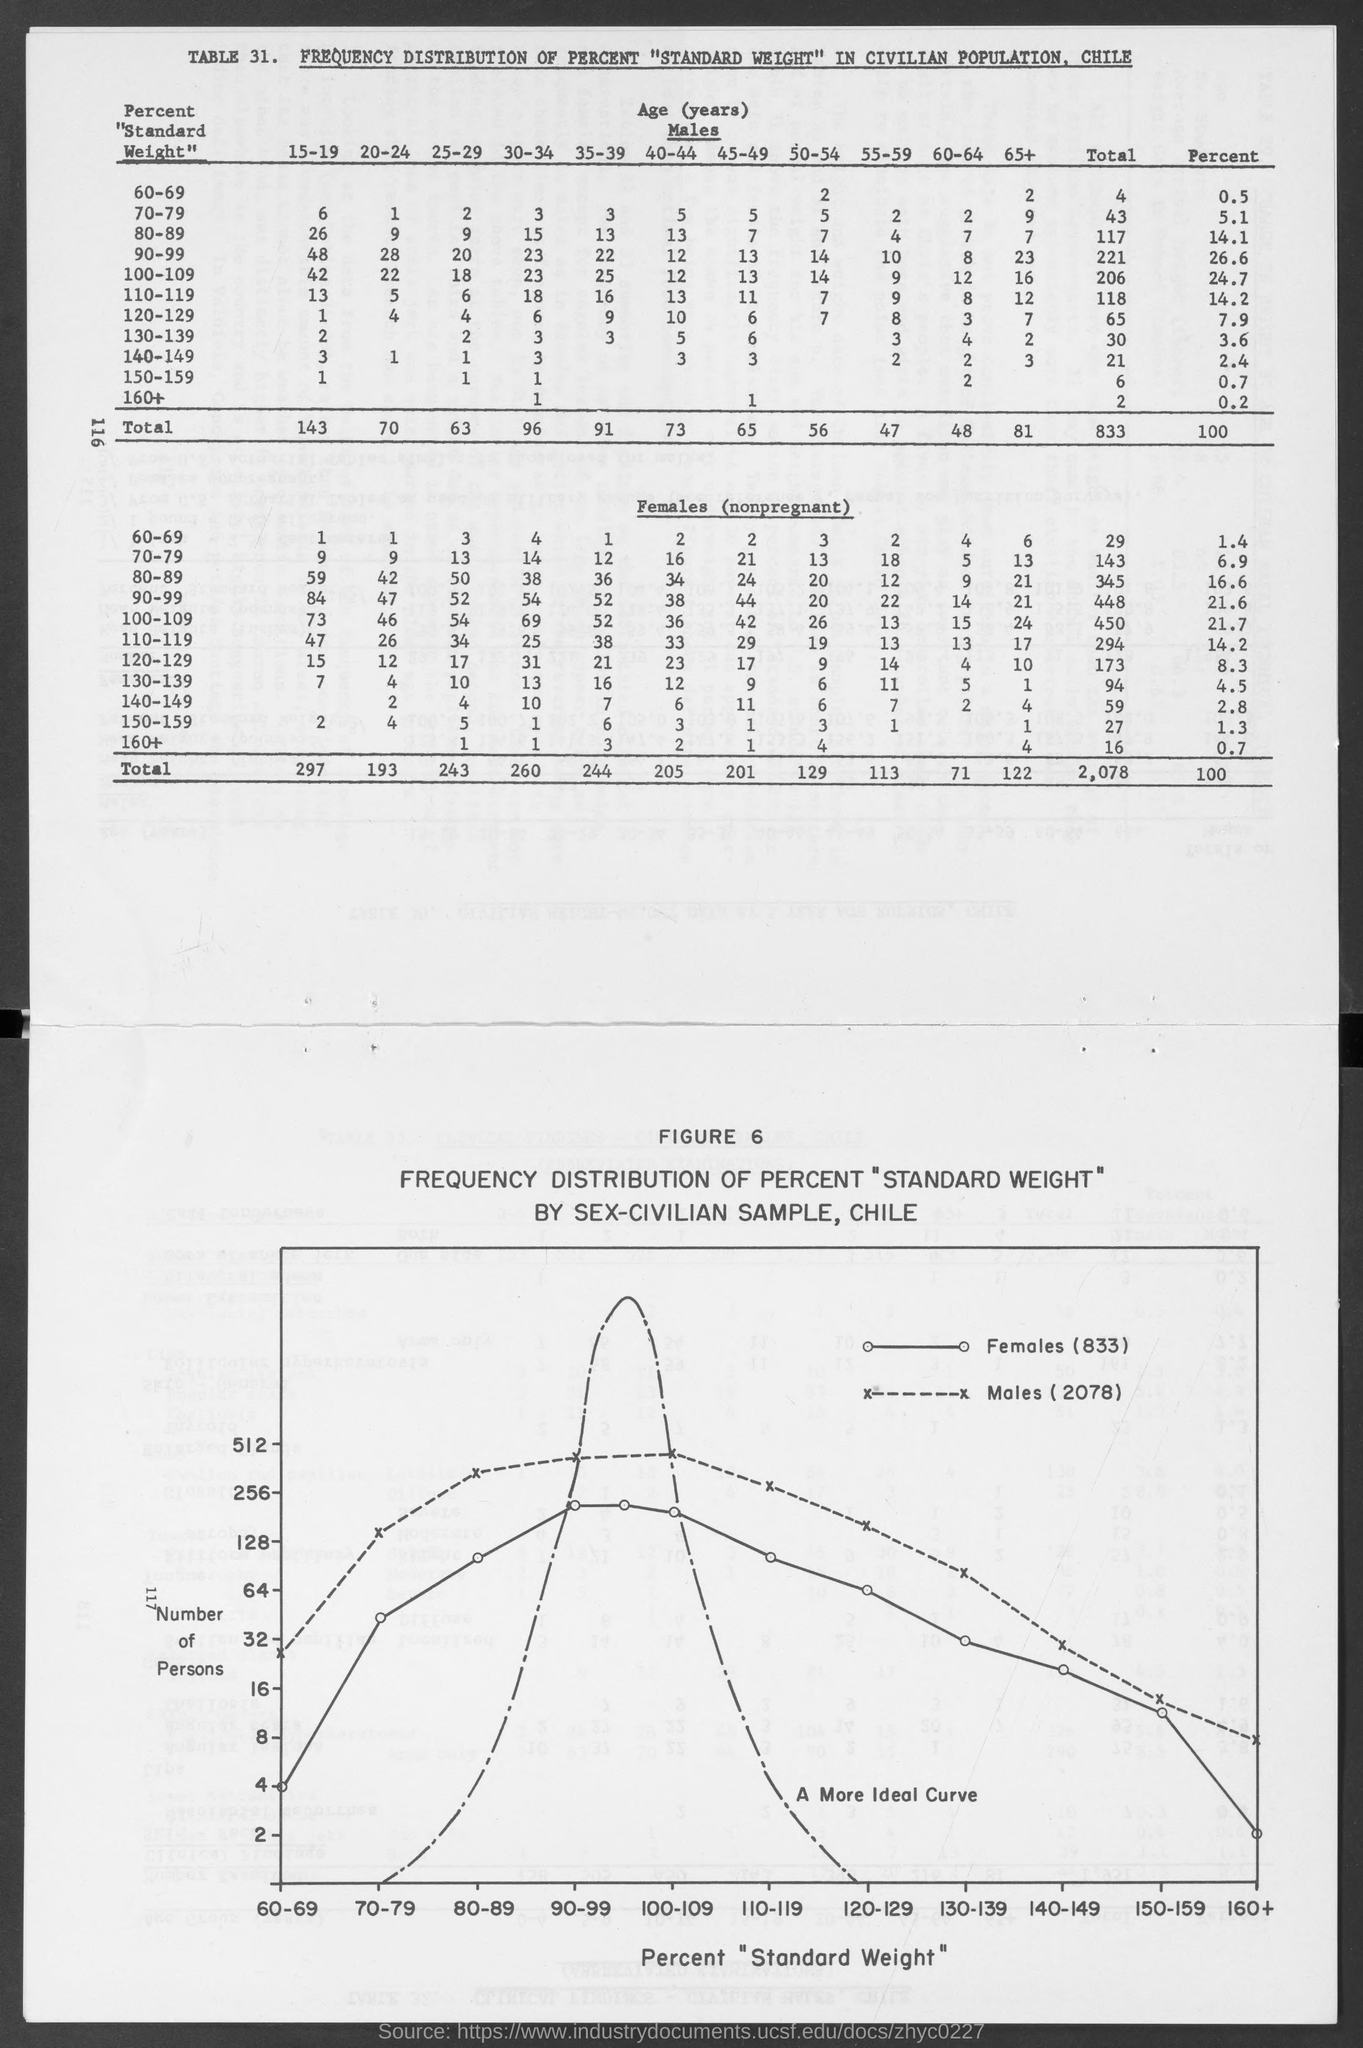What is the number of Figure?
Offer a terse response. 6. What is plotted on the y-axis?
Provide a succinct answer. Number of Persons. What is the number of females mentioned in the graph?
Offer a very short reply. 833. What is the number of males mentioned in the graph?
Offer a very short reply. 2078. Percentage of males of weight 60-69?
Provide a short and direct response. 0.5. Percentage of males of weight 150-159?
Ensure brevity in your answer.  0.7. What is the total number of males of weight 60-69?
Your answer should be compact. 4. What is the total number of females of weight 60-69?
Your answer should be compact. 29. Percentage of females of weight 150-159?
Offer a terse response. 1.3. What is the table number?
Provide a succinct answer. 31. 